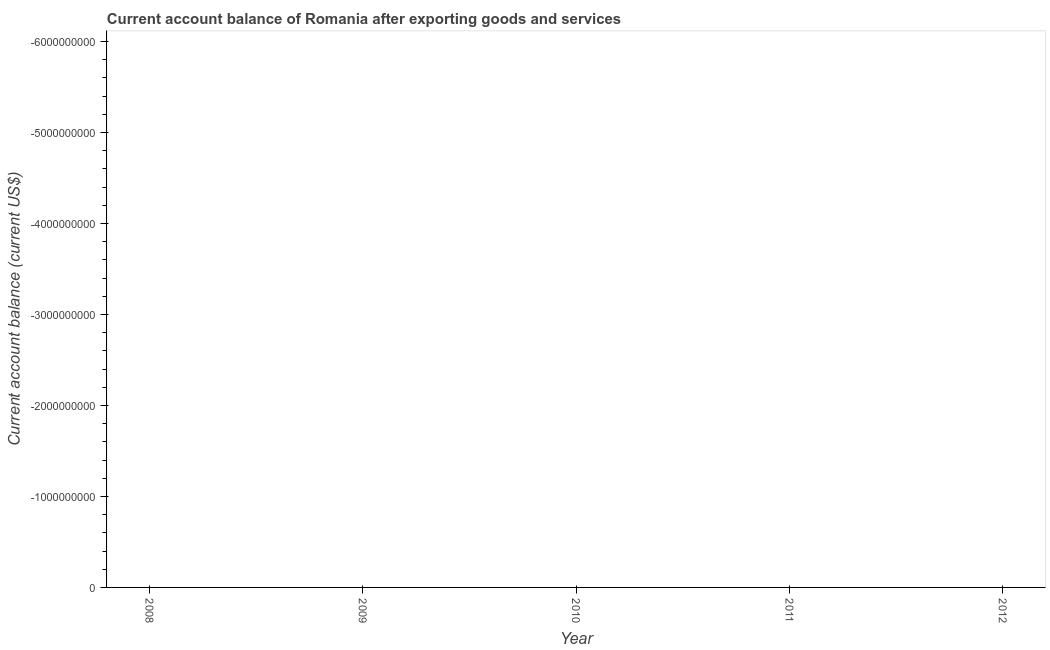What is the current account balance in 2012?
Provide a succinct answer. 0. Across all years, what is the minimum current account balance?
Provide a succinct answer. 0. What is the average current account balance per year?
Offer a very short reply. 0. What is the median current account balance?
Ensure brevity in your answer.  0. In how many years, is the current account balance greater than -1400000000 US$?
Your response must be concise. 0. In how many years, is the current account balance greater than the average current account balance taken over all years?
Your response must be concise. 0. Does the current account balance monotonically increase over the years?
Offer a very short reply. No. How many dotlines are there?
Ensure brevity in your answer.  0. How many years are there in the graph?
Ensure brevity in your answer.  5. What is the difference between two consecutive major ticks on the Y-axis?
Your answer should be compact. 1.00e+09. Does the graph contain any zero values?
Offer a very short reply. Yes. What is the title of the graph?
Provide a short and direct response. Current account balance of Romania after exporting goods and services. What is the label or title of the Y-axis?
Provide a short and direct response. Current account balance (current US$). What is the Current account balance (current US$) in 2008?
Keep it short and to the point. 0. What is the Current account balance (current US$) in 2010?
Offer a terse response. 0. What is the Current account balance (current US$) in 2011?
Provide a short and direct response. 0. What is the Current account balance (current US$) in 2012?
Your answer should be very brief. 0. 